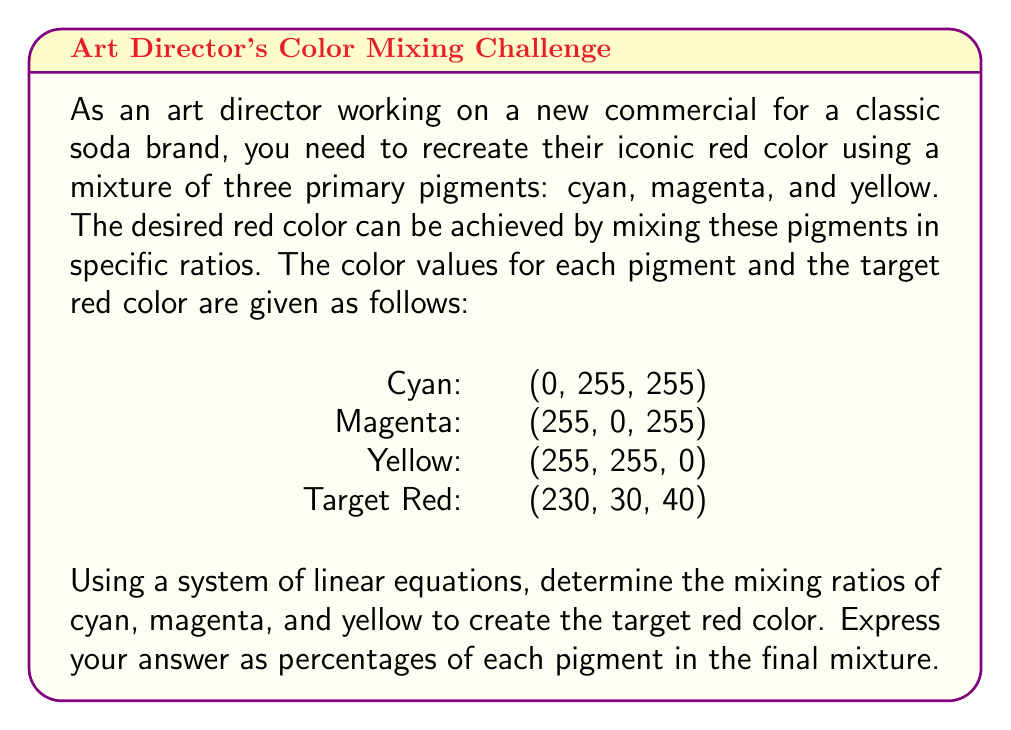Show me your answer to this math problem. To solve this problem, we need to set up a system of linear equations based on the RGB values of each pigment and the target color. Let's denote the ratios of cyan, magenta, and yellow as $x$, $y$, and $z$ respectively.

1. Set up the system of equations:

For the red channel: $0x + 255y + 255z = 230$
For the green channel: $255x + 0y + 255z = 30$
For the blue channel: $255x + 255y + 0z = 40$

2. Write the system in matrix form:

$$
\begin{bmatrix}
0 & 255 & 255 \\
255 & 0 & 255 \\
255 & 255 & 0
\end{bmatrix}
\begin{bmatrix}
x \\
y \\
z
\end{bmatrix}
=
\begin{bmatrix}
230 \\
30 \\
40
\end{bmatrix}
$$

3. Solve the system using Gaussian elimination or matrix inversion. After calculations, we get:

$$
\begin{bmatrix}
x \\
y \\
z
\end{bmatrix}
=
\begin{bmatrix}
0.0745 \\
0.1255 \\
0.8000
\end{bmatrix}
$$

4. Convert the ratios to percentages:

Cyan: $0.0745 \times 100\% = 7.45\%$
Magenta: $0.1255 \times 100\% = 12.55\%$
Yellow: $0.8000 \times 100\% = 80.00\%$

5. Verify that the percentages sum to 100%:

$7.45\% + 12.55\% + 80.00\% = 100\%$

This confirms that our solution is valid.
Answer: The mixing ratios for the target red color are:
Cyan: 7.45%
Magenta: 12.55%
Yellow: 80.00% 